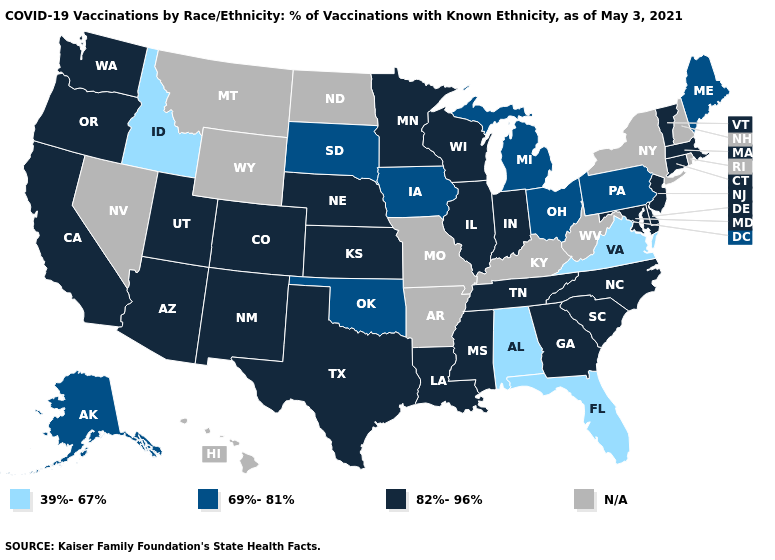Does South Dakota have the highest value in the MidWest?
Give a very brief answer. No. What is the value of Illinois?
Keep it brief. 82%-96%. What is the value of New Hampshire?
Concise answer only. N/A. Among the states that border North Carolina , which have the lowest value?
Be succinct. Virginia. What is the lowest value in the Northeast?
Quick response, please. 69%-81%. Which states have the highest value in the USA?
Short answer required. Arizona, California, Colorado, Connecticut, Delaware, Georgia, Illinois, Indiana, Kansas, Louisiana, Maryland, Massachusetts, Minnesota, Mississippi, Nebraska, New Jersey, New Mexico, North Carolina, Oregon, South Carolina, Tennessee, Texas, Utah, Vermont, Washington, Wisconsin. Does Minnesota have the highest value in the MidWest?
Be succinct. Yes. What is the value of Mississippi?
Keep it brief. 82%-96%. Among the states that border New York , which have the lowest value?
Answer briefly. Pennsylvania. Name the states that have a value in the range N/A?
Give a very brief answer. Arkansas, Hawaii, Kentucky, Missouri, Montana, Nevada, New Hampshire, New York, North Dakota, Rhode Island, West Virginia, Wyoming. What is the value of Florida?
Quick response, please. 39%-67%. Is the legend a continuous bar?
Quick response, please. No. Does the map have missing data?
Write a very short answer. Yes. Name the states that have a value in the range N/A?
Quick response, please. Arkansas, Hawaii, Kentucky, Missouri, Montana, Nevada, New Hampshire, New York, North Dakota, Rhode Island, West Virginia, Wyoming. 